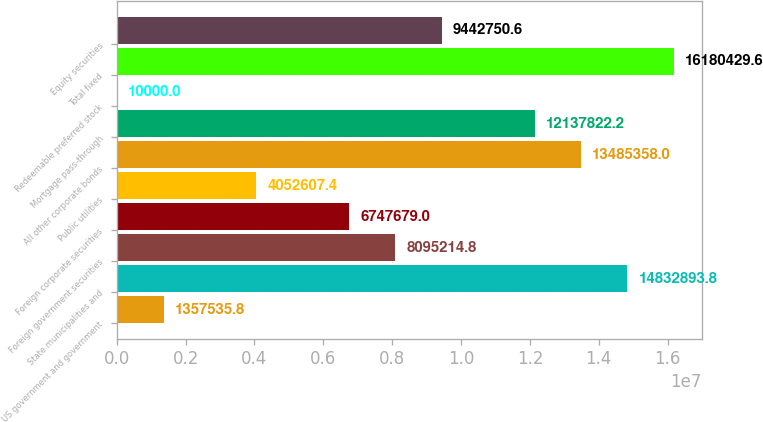Convert chart. <chart><loc_0><loc_0><loc_500><loc_500><bar_chart><fcel>US government and government<fcel>State municipalities and<fcel>Foreign government securities<fcel>Foreign corporate securities<fcel>Public utilities<fcel>All other corporate bonds<fcel>Mortgage pass-through<fcel>Redeemable preferred stock<fcel>Total fixed<fcel>Equity securities<nl><fcel>1.35754e+06<fcel>1.48329e+07<fcel>8.09521e+06<fcel>6.74768e+06<fcel>4.05261e+06<fcel>1.34854e+07<fcel>1.21378e+07<fcel>10000<fcel>1.61804e+07<fcel>9.44275e+06<nl></chart> 